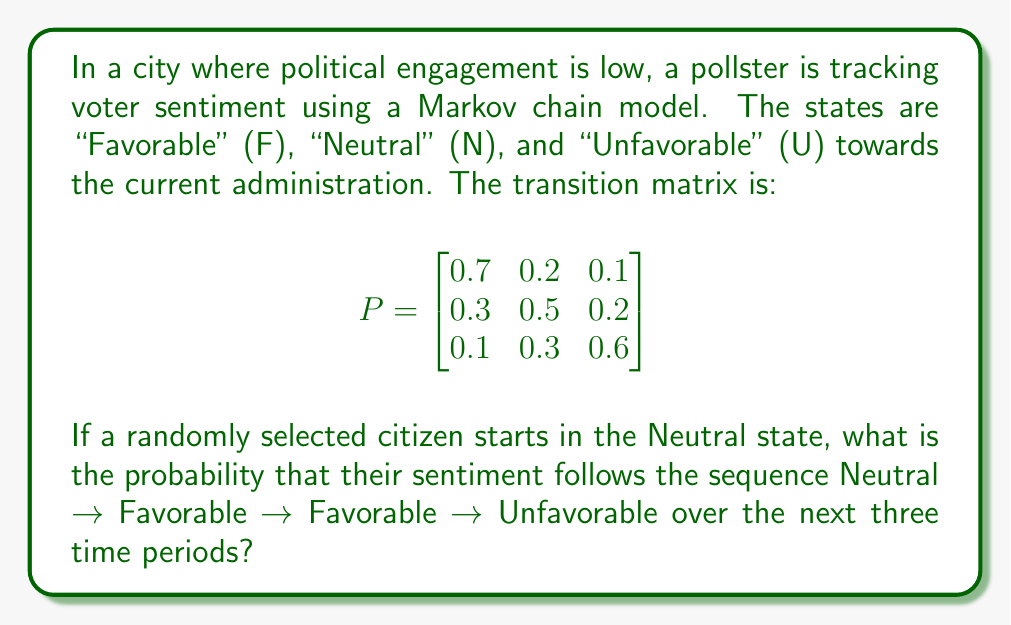Teach me how to tackle this problem. To solve this problem, we'll use the properties of Markov chains and the given transition matrix. We need to calculate the probability of the sequence N → F → F → U.

Step 1: Identify the required transitions
- N → F (Neutral to Favorable)
- F → F (Favorable to Favorable)
- F → U (Favorable to Unfavorable)

Step 2: Find the probabilities for each transition from the matrix
- P(N → F) = 0.3 (row 2, column 1)
- P(F → F) = 0.7 (row 1, column 1)
- P(F → U) = 0.1 (row 1, column 3)

Step 3: Calculate the joint probability
The probability of this specific sequence occurring is the product of the individual transition probabilities:

$$P(\text{N} \rightarrow \text{F} \rightarrow \text{F} \rightarrow \text{U}) = P(\text{N} \rightarrow \text{F}) \times P(\text{F} \rightarrow \text{F}) \times P(\text{F} \rightarrow \text{U})$$

$$= 0.3 \times 0.7 \times 0.1$$

$$= 0.021$$

Therefore, the probability of observing this specific sequence is 0.021 or 2.1%.
Answer: 0.021 